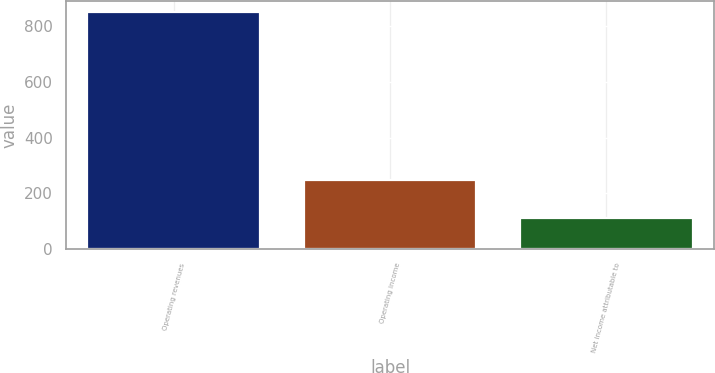<chart> <loc_0><loc_0><loc_500><loc_500><bar_chart><fcel>Operating revenues<fcel>Operating income<fcel>Net income attributable to<nl><fcel>850<fcel>248<fcel>112<nl></chart> 